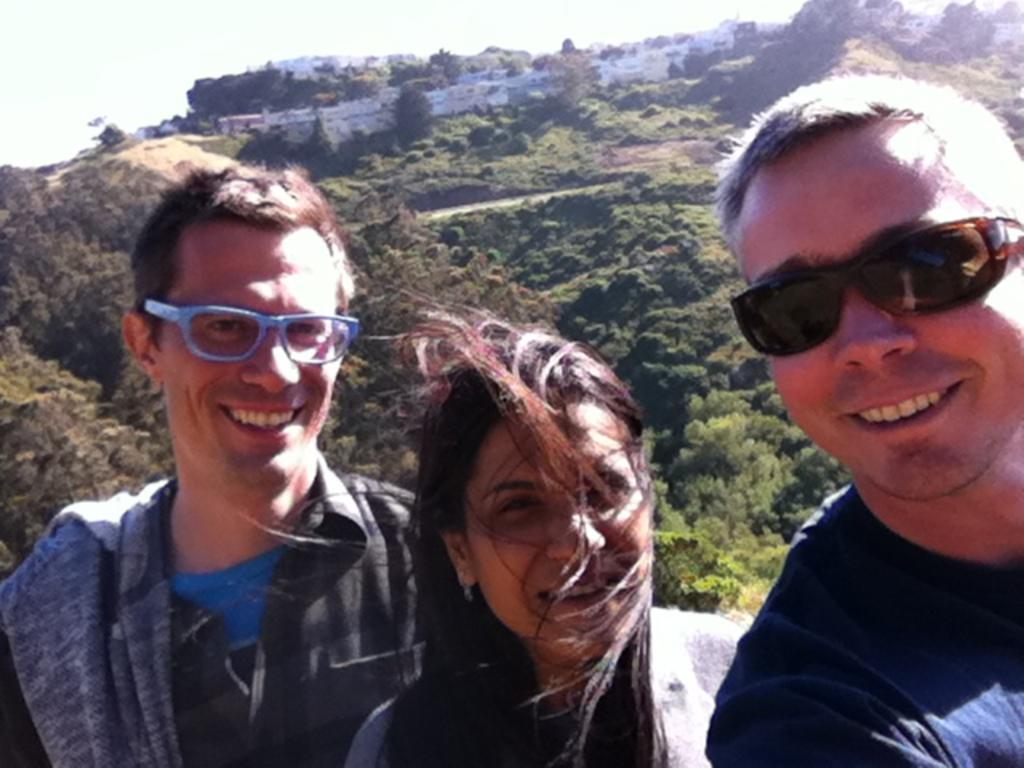Could you give a brief overview of what you see in this image? In this image we can see persons laughing. In the background we can see trees, hills, buildings and sky. 